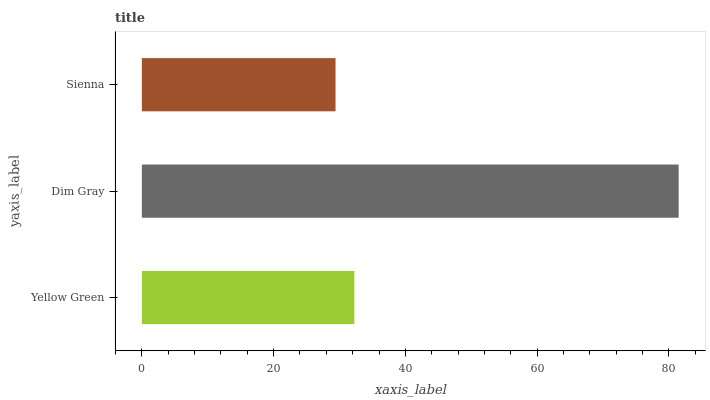Is Sienna the minimum?
Answer yes or no. Yes. Is Dim Gray the maximum?
Answer yes or no. Yes. Is Dim Gray the minimum?
Answer yes or no. No. Is Sienna the maximum?
Answer yes or no. No. Is Dim Gray greater than Sienna?
Answer yes or no. Yes. Is Sienna less than Dim Gray?
Answer yes or no. Yes. Is Sienna greater than Dim Gray?
Answer yes or no. No. Is Dim Gray less than Sienna?
Answer yes or no. No. Is Yellow Green the high median?
Answer yes or no. Yes. Is Yellow Green the low median?
Answer yes or no. Yes. Is Sienna the high median?
Answer yes or no. No. Is Sienna the low median?
Answer yes or no. No. 